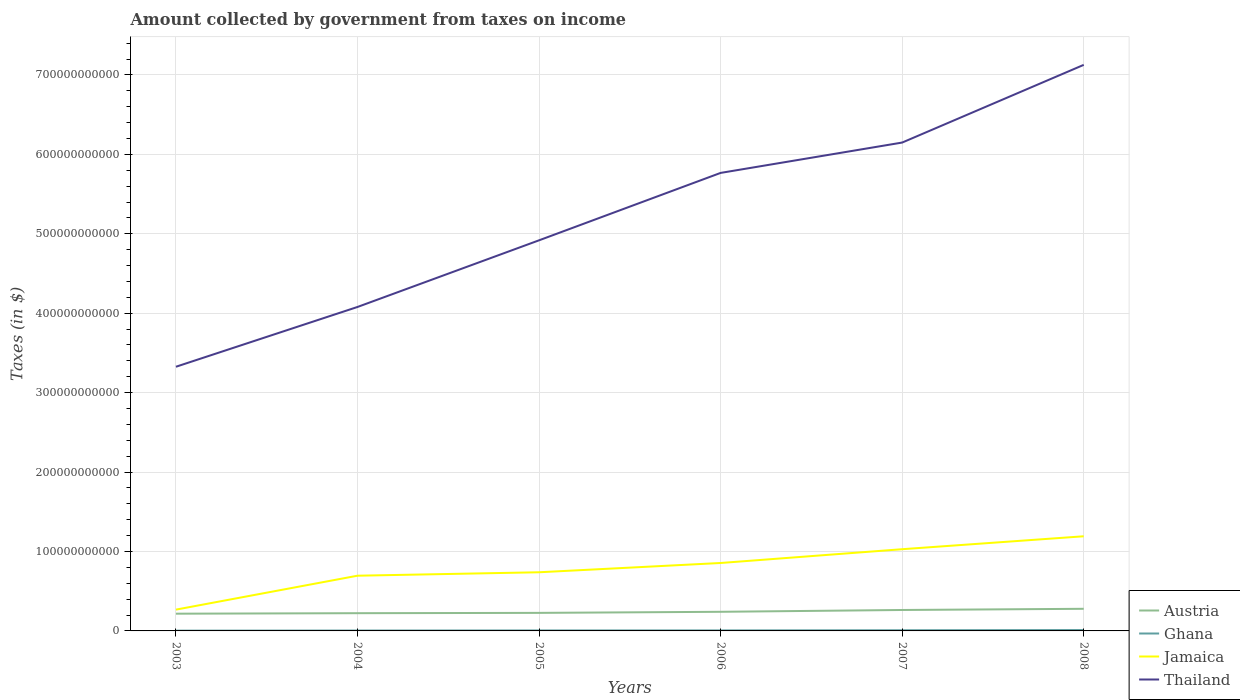How many different coloured lines are there?
Your answer should be compact. 4. Does the line corresponding to Ghana intersect with the line corresponding to Austria?
Make the answer very short. No. Is the number of lines equal to the number of legend labels?
Offer a very short reply. Yes. Across all years, what is the maximum amount collected by government from taxes on income in Thailand?
Your response must be concise. 3.33e+11. What is the total amount collected by government from taxes on income in Jamaica in the graph?
Offer a very short reply. -7.61e+1. What is the difference between the highest and the second highest amount collected by government from taxes on income in Jamaica?
Your answer should be very brief. 9.24e+1. How many lines are there?
Offer a terse response. 4. How many years are there in the graph?
Make the answer very short. 6. What is the difference between two consecutive major ticks on the Y-axis?
Your answer should be compact. 1.00e+11. What is the title of the graph?
Your answer should be compact. Amount collected by government from taxes on income. Does "China" appear as one of the legend labels in the graph?
Give a very brief answer. No. What is the label or title of the X-axis?
Provide a short and direct response. Years. What is the label or title of the Y-axis?
Keep it short and to the point. Taxes (in $). What is the Taxes (in $) of Austria in 2003?
Offer a very short reply. 2.17e+1. What is the Taxes (in $) of Ghana in 2003?
Offer a terse response. 3.57e+08. What is the Taxes (in $) in Jamaica in 2003?
Your answer should be compact. 2.68e+1. What is the Taxes (in $) of Thailand in 2003?
Give a very brief answer. 3.33e+11. What is the Taxes (in $) in Austria in 2004?
Ensure brevity in your answer.  2.23e+1. What is the Taxes (in $) of Ghana in 2004?
Provide a succinct answer. 4.86e+08. What is the Taxes (in $) of Jamaica in 2004?
Your answer should be very brief. 6.95e+1. What is the Taxes (in $) of Thailand in 2004?
Ensure brevity in your answer.  4.08e+11. What is the Taxes (in $) of Austria in 2005?
Give a very brief answer. 2.27e+1. What is the Taxes (in $) of Ghana in 2005?
Keep it short and to the point. 6.09e+08. What is the Taxes (in $) in Jamaica in 2005?
Your answer should be compact. 7.38e+1. What is the Taxes (in $) in Thailand in 2005?
Provide a succinct answer. 4.92e+11. What is the Taxes (in $) in Austria in 2006?
Ensure brevity in your answer.  2.41e+1. What is the Taxes (in $) in Ghana in 2006?
Your answer should be very brief. 6.58e+08. What is the Taxes (in $) of Jamaica in 2006?
Offer a terse response. 8.55e+1. What is the Taxes (in $) in Thailand in 2006?
Make the answer very short. 5.77e+11. What is the Taxes (in $) of Austria in 2007?
Your answer should be compact. 2.64e+1. What is the Taxes (in $) of Ghana in 2007?
Make the answer very short. 8.57e+08. What is the Taxes (in $) in Jamaica in 2007?
Keep it short and to the point. 1.03e+11. What is the Taxes (in $) of Thailand in 2007?
Your answer should be compact. 6.15e+11. What is the Taxes (in $) in Austria in 2008?
Offer a very short reply. 2.79e+1. What is the Taxes (in $) in Ghana in 2008?
Offer a very short reply. 1.13e+09. What is the Taxes (in $) in Jamaica in 2008?
Keep it short and to the point. 1.19e+11. What is the Taxes (in $) in Thailand in 2008?
Offer a terse response. 7.13e+11. Across all years, what is the maximum Taxes (in $) of Austria?
Provide a succinct answer. 2.79e+1. Across all years, what is the maximum Taxes (in $) of Ghana?
Provide a short and direct response. 1.13e+09. Across all years, what is the maximum Taxes (in $) of Jamaica?
Offer a very short reply. 1.19e+11. Across all years, what is the maximum Taxes (in $) of Thailand?
Provide a short and direct response. 7.13e+11. Across all years, what is the minimum Taxes (in $) in Austria?
Provide a short and direct response. 2.17e+1. Across all years, what is the minimum Taxes (in $) of Ghana?
Keep it short and to the point. 3.57e+08. Across all years, what is the minimum Taxes (in $) in Jamaica?
Keep it short and to the point. 2.68e+1. Across all years, what is the minimum Taxes (in $) of Thailand?
Provide a short and direct response. 3.33e+11. What is the total Taxes (in $) in Austria in the graph?
Your answer should be compact. 1.45e+11. What is the total Taxes (in $) in Ghana in the graph?
Offer a terse response. 4.10e+09. What is the total Taxes (in $) of Jamaica in the graph?
Ensure brevity in your answer.  4.78e+11. What is the total Taxes (in $) in Thailand in the graph?
Give a very brief answer. 3.14e+12. What is the difference between the Taxes (in $) of Austria in 2003 and that in 2004?
Provide a succinct answer. -6.12e+08. What is the difference between the Taxes (in $) of Ghana in 2003 and that in 2004?
Give a very brief answer. -1.29e+08. What is the difference between the Taxes (in $) of Jamaica in 2003 and that in 2004?
Your response must be concise. -4.27e+1. What is the difference between the Taxes (in $) of Thailand in 2003 and that in 2004?
Your answer should be very brief. -7.53e+1. What is the difference between the Taxes (in $) in Austria in 2003 and that in 2005?
Offer a terse response. -1.02e+09. What is the difference between the Taxes (in $) in Ghana in 2003 and that in 2005?
Provide a succinct answer. -2.52e+08. What is the difference between the Taxes (in $) of Jamaica in 2003 and that in 2005?
Keep it short and to the point. -4.70e+1. What is the difference between the Taxes (in $) in Thailand in 2003 and that in 2005?
Your answer should be very brief. -1.59e+11. What is the difference between the Taxes (in $) of Austria in 2003 and that in 2006?
Offer a terse response. -2.36e+09. What is the difference between the Taxes (in $) in Ghana in 2003 and that in 2006?
Your answer should be compact. -3.01e+08. What is the difference between the Taxes (in $) of Jamaica in 2003 and that in 2006?
Keep it short and to the point. -5.87e+1. What is the difference between the Taxes (in $) in Thailand in 2003 and that in 2006?
Offer a terse response. -2.44e+11. What is the difference between the Taxes (in $) in Austria in 2003 and that in 2007?
Your answer should be very brief. -4.66e+09. What is the difference between the Taxes (in $) in Ghana in 2003 and that in 2007?
Ensure brevity in your answer.  -5.01e+08. What is the difference between the Taxes (in $) of Jamaica in 2003 and that in 2007?
Provide a succinct answer. -7.61e+1. What is the difference between the Taxes (in $) of Thailand in 2003 and that in 2007?
Provide a succinct answer. -2.82e+11. What is the difference between the Taxes (in $) of Austria in 2003 and that in 2008?
Provide a short and direct response. -6.15e+09. What is the difference between the Taxes (in $) in Ghana in 2003 and that in 2008?
Your answer should be very brief. -7.78e+08. What is the difference between the Taxes (in $) of Jamaica in 2003 and that in 2008?
Your response must be concise. -9.24e+1. What is the difference between the Taxes (in $) in Thailand in 2003 and that in 2008?
Ensure brevity in your answer.  -3.80e+11. What is the difference between the Taxes (in $) of Austria in 2004 and that in 2005?
Your response must be concise. -4.04e+08. What is the difference between the Taxes (in $) of Ghana in 2004 and that in 2005?
Provide a succinct answer. -1.23e+08. What is the difference between the Taxes (in $) in Jamaica in 2004 and that in 2005?
Make the answer very short. -4.33e+09. What is the difference between the Taxes (in $) of Thailand in 2004 and that in 2005?
Offer a very short reply. -8.39e+1. What is the difference between the Taxes (in $) of Austria in 2004 and that in 2006?
Make the answer very short. -1.75e+09. What is the difference between the Taxes (in $) in Ghana in 2004 and that in 2006?
Provide a succinct answer. -1.72e+08. What is the difference between the Taxes (in $) of Jamaica in 2004 and that in 2006?
Your answer should be compact. -1.60e+1. What is the difference between the Taxes (in $) of Thailand in 2004 and that in 2006?
Your answer should be very brief. -1.69e+11. What is the difference between the Taxes (in $) of Austria in 2004 and that in 2007?
Provide a short and direct response. -4.04e+09. What is the difference between the Taxes (in $) of Ghana in 2004 and that in 2007?
Offer a terse response. -3.72e+08. What is the difference between the Taxes (in $) in Jamaica in 2004 and that in 2007?
Offer a terse response. -3.34e+1. What is the difference between the Taxes (in $) in Thailand in 2004 and that in 2007?
Provide a succinct answer. -2.07e+11. What is the difference between the Taxes (in $) of Austria in 2004 and that in 2008?
Your response must be concise. -5.54e+09. What is the difference between the Taxes (in $) of Ghana in 2004 and that in 2008?
Give a very brief answer. -6.49e+08. What is the difference between the Taxes (in $) of Jamaica in 2004 and that in 2008?
Make the answer very short. -4.97e+1. What is the difference between the Taxes (in $) in Thailand in 2004 and that in 2008?
Your response must be concise. -3.05e+11. What is the difference between the Taxes (in $) in Austria in 2005 and that in 2006?
Ensure brevity in your answer.  -1.35e+09. What is the difference between the Taxes (in $) in Ghana in 2005 and that in 2006?
Your response must be concise. -4.90e+07. What is the difference between the Taxes (in $) in Jamaica in 2005 and that in 2006?
Give a very brief answer. -1.17e+1. What is the difference between the Taxes (in $) in Thailand in 2005 and that in 2006?
Provide a short and direct response. -8.49e+1. What is the difference between the Taxes (in $) of Austria in 2005 and that in 2007?
Your answer should be compact. -3.64e+09. What is the difference between the Taxes (in $) of Ghana in 2005 and that in 2007?
Offer a terse response. -2.48e+08. What is the difference between the Taxes (in $) in Jamaica in 2005 and that in 2007?
Provide a short and direct response. -2.90e+1. What is the difference between the Taxes (in $) of Thailand in 2005 and that in 2007?
Your answer should be very brief. -1.23e+11. What is the difference between the Taxes (in $) in Austria in 2005 and that in 2008?
Your answer should be compact. -5.14e+09. What is the difference between the Taxes (in $) of Ghana in 2005 and that in 2008?
Your answer should be compact. -5.26e+08. What is the difference between the Taxes (in $) of Jamaica in 2005 and that in 2008?
Make the answer very short. -4.53e+1. What is the difference between the Taxes (in $) in Thailand in 2005 and that in 2008?
Provide a short and direct response. -2.21e+11. What is the difference between the Taxes (in $) of Austria in 2006 and that in 2007?
Your answer should be compact. -2.29e+09. What is the difference between the Taxes (in $) in Ghana in 2006 and that in 2007?
Your answer should be very brief. -1.99e+08. What is the difference between the Taxes (in $) in Jamaica in 2006 and that in 2007?
Ensure brevity in your answer.  -1.74e+1. What is the difference between the Taxes (in $) in Thailand in 2006 and that in 2007?
Your response must be concise. -3.82e+1. What is the difference between the Taxes (in $) of Austria in 2006 and that in 2008?
Provide a short and direct response. -3.79e+09. What is the difference between the Taxes (in $) in Ghana in 2006 and that in 2008?
Keep it short and to the point. -4.77e+08. What is the difference between the Taxes (in $) in Jamaica in 2006 and that in 2008?
Give a very brief answer. -3.36e+1. What is the difference between the Taxes (in $) of Thailand in 2006 and that in 2008?
Your response must be concise. -1.36e+11. What is the difference between the Taxes (in $) in Austria in 2007 and that in 2008?
Provide a succinct answer. -1.50e+09. What is the difference between the Taxes (in $) of Ghana in 2007 and that in 2008?
Provide a succinct answer. -2.77e+08. What is the difference between the Taxes (in $) in Jamaica in 2007 and that in 2008?
Make the answer very short. -1.63e+1. What is the difference between the Taxes (in $) of Thailand in 2007 and that in 2008?
Offer a terse response. -9.78e+1. What is the difference between the Taxes (in $) in Austria in 2003 and the Taxes (in $) in Ghana in 2004?
Offer a terse response. 2.12e+1. What is the difference between the Taxes (in $) of Austria in 2003 and the Taxes (in $) of Jamaica in 2004?
Offer a terse response. -4.78e+1. What is the difference between the Taxes (in $) of Austria in 2003 and the Taxes (in $) of Thailand in 2004?
Keep it short and to the point. -3.86e+11. What is the difference between the Taxes (in $) of Ghana in 2003 and the Taxes (in $) of Jamaica in 2004?
Offer a very short reply. -6.92e+1. What is the difference between the Taxes (in $) of Ghana in 2003 and the Taxes (in $) of Thailand in 2004?
Offer a terse response. -4.08e+11. What is the difference between the Taxes (in $) in Jamaica in 2003 and the Taxes (in $) in Thailand in 2004?
Provide a short and direct response. -3.81e+11. What is the difference between the Taxes (in $) in Austria in 2003 and the Taxes (in $) in Ghana in 2005?
Your answer should be compact. 2.11e+1. What is the difference between the Taxes (in $) in Austria in 2003 and the Taxes (in $) in Jamaica in 2005?
Give a very brief answer. -5.21e+1. What is the difference between the Taxes (in $) in Austria in 2003 and the Taxes (in $) in Thailand in 2005?
Make the answer very short. -4.70e+11. What is the difference between the Taxes (in $) of Ghana in 2003 and the Taxes (in $) of Jamaica in 2005?
Provide a short and direct response. -7.35e+1. What is the difference between the Taxes (in $) of Ghana in 2003 and the Taxes (in $) of Thailand in 2005?
Your answer should be very brief. -4.91e+11. What is the difference between the Taxes (in $) of Jamaica in 2003 and the Taxes (in $) of Thailand in 2005?
Keep it short and to the point. -4.65e+11. What is the difference between the Taxes (in $) in Austria in 2003 and the Taxes (in $) in Ghana in 2006?
Keep it short and to the point. 2.10e+1. What is the difference between the Taxes (in $) of Austria in 2003 and the Taxes (in $) of Jamaica in 2006?
Keep it short and to the point. -6.38e+1. What is the difference between the Taxes (in $) of Austria in 2003 and the Taxes (in $) of Thailand in 2006?
Offer a terse response. -5.55e+11. What is the difference between the Taxes (in $) of Ghana in 2003 and the Taxes (in $) of Jamaica in 2006?
Your answer should be very brief. -8.52e+1. What is the difference between the Taxes (in $) of Ghana in 2003 and the Taxes (in $) of Thailand in 2006?
Ensure brevity in your answer.  -5.76e+11. What is the difference between the Taxes (in $) in Jamaica in 2003 and the Taxes (in $) in Thailand in 2006?
Offer a very short reply. -5.50e+11. What is the difference between the Taxes (in $) of Austria in 2003 and the Taxes (in $) of Ghana in 2007?
Your answer should be very brief. 2.08e+1. What is the difference between the Taxes (in $) in Austria in 2003 and the Taxes (in $) in Jamaica in 2007?
Provide a succinct answer. -8.12e+1. What is the difference between the Taxes (in $) of Austria in 2003 and the Taxes (in $) of Thailand in 2007?
Give a very brief answer. -5.93e+11. What is the difference between the Taxes (in $) in Ghana in 2003 and the Taxes (in $) in Jamaica in 2007?
Ensure brevity in your answer.  -1.03e+11. What is the difference between the Taxes (in $) in Ghana in 2003 and the Taxes (in $) in Thailand in 2007?
Provide a short and direct response. -6.15e+11. What is the difference between the Taxes (in $) in Jamaica in 2003 and the Taxes (in $) in Thailand in 2007?
Offer a very short reply. -5.88e+11. What is the difference between the Taxes (in $) in Austria in 2003 and the Taxes (in $) in Ghana in 2008?
Keep it short and to the point. 2.06e+1. What is the difference between the Taxes (in $) of Austria in 2003 and the Taxes (in $) of Jamaica in 2008?
Offer a very short reply. -9.75e+1. What is the difference between the Taxes (in $) in Austria in 2003 and the Taxes (in $) in Thailand in 2008?
Ensure brevity in your answer.  -6.91e+11. What is the difference between the Taxes (in $) in Ghana in 2003 and the Taxes (in $) in Jamaica in 2008?
Your answer should be very brief. -1.19e+11. What is the difference between the Taxes (in $) of Ghana in 2003 and the Taxes (in $) of Thailand in 2008?
Your answer should be compact. -7.12e+11. What is the difference between the Taxes (in $) of Jamaica in 2003 and the Taxes (in $) of Thailand in 2008?
Make the answer very short. -6.86e+11. What is the difference between the Taxes (in $) in Austria in 2004 and the Taxes (in $) in Ghana in 2005?
Your answer should be very brief. 2.17e+1. What is the difference between the Taxes (in $) of Austria in 2004 and the Taxes (in $) of Jamaica in 2005?
Make the answer very short. -5.15e+1. What is the difference between the Taxes (in $) in Austria in 2004 and the Taxes (in $) in Thailand in 2005?
Your answer should be very brief. -4.69e+11. What is the difference between the Taxes (in $) in Ghana in 2004 and the Taxes (in $) in Jamaica in 2005?
Your answer should be very brief. -7.34e+1. What is the difference between the Taxes (in $) in Ghana in 2004 and the Taxes (in $) in Thailand in 2005?
Offer a terse response. -4.91e+11. What is the difference between the Taxes (in $) of Jamaica in 2004 and the Taxes (in $) of Thailand in 2005?
Provide a short and direct response. -4.22e+11. What is the difference between the Taxes (in $) in Austria in 2004 and the Taxes (in $) in Ghana in 2006?
Keep it short and to the point. 2.17e+1. What is the difference between the Taxes (in $) of Austria in 2004 and the Taxes (in $) of Jamaica in 2006?
Offer a terse response. -6.32e+1. What is the difference between the Taxes (in $) of Austria in 2004 and the Taxes (in $) of Thailand in 2006?
Your answer should be compact. -5.54e+11. What is the difference between the Taxes (in $) in Ghana in 2004 and the Taxes (in $) in Jamaica in 2006?
Keep it short and to the point. -8.50e+1. What is the difference between the Taxes (in $) in Ghana in 2004 and the Taxes (in $) in Thailand in 2006?
Offer a very short reply. -5.76e+11. What is the difference between the Taxes (in $) in Jamaica in 2004 and the Taxes (in $) in Thailand in 2006?
Offer a very short reply. -5.07e+11. What is the difference between the Taxes (in $) of Austria in 2004 and the Taxes (in $) of Ghana in 2007?
Ensure brevity in your answer.  2.15e+1. What is the difference between the Taxes (in $) in Austria in 2004 and the Taxes (in $) in Jamaica in 2007?
Provide a succinct answer. -8.06e+1. What is the difference between the Taxes (in $) in Austria in 2004 and the Taxes (in $) in Thailand in 2007?
Offer a terse response. -5.93e+11. What is the difference between the Taxes (in $) in Ghana in 2004 and the Taxes (in $) in Jamaica in 2007?
Offer a very short reply. -1.02e+11. What is the difference between the Taxes (in $) of Ghana in 2004 and the Taxes (in $) of Thailand in 2007?
Provide a short and direct response. -6.14e+11. What is the difference between the Taxes (in $) of Jamaica in 2004 and the Taxes (in $) of Thailand in 2007?
Offer a terse response. -5.45e+11. What is the difference between the Taxes (in $) in Austria in 2004 and the Taxes (in $) in Ghana in 2008?
Provide a short and direct response. 2.12e+1. What is the difference between the Taxes (in $) in Austria in 2004 and the Taxes (in $) in Jamaica in 2008?
Your answer should be very brief. -9.68e+1. What is the difference between the Taxes (in $) of Austria in 2004 and the Taxes (in $) of Thailand in 2008?
Provide a short and direct response. -6.90e+11. What is the difference between the Taxes (in $) of Ghana in 2004 and the Taxes (in $) of Jamaica in 2008?
Your answer should be compact. -1.19e+11. What is the difference between the Taxes (in $) of Ghana in 2004 and the Taxes (in $) of Thailand in 2008?
Your response must be concise. -7.12e+11. What is the difference between the Taxes (in $) of Jamaica in 2004 and the Taxes (in $) of Thailand in 2008?
Provide a short and direct response. -6.43e+11. What is the difference between the Taxes (in $) in Austria in 2005 and the Taxes (in $) in Ghana in 2006?
Your answer should be compact. 2.21e+1. What is the difference between the Taxes (in $) of Austria in 2005 and the Taxes (in $) of Jamaica in 2006?
Your answer should be compact. -6.28e+1. What is the difference between the Taxes (in $) in Austria in 2005 and the Taxes (in $) in Thailand in 2006?
Provide a short and direct response. -5.54e+11. What is the difference between the Taxes (in $) in Ghana in 2005 and the Taxes (in $) in Jamaica in 2006?
Ensure brevity in your answer.  -8.49e+1. What is the difference between the Taxes (in $) in Ghana in 2005 and the Taxes (in $) in Thailand in 2006?
Your answer should be very brief. -5.76e+11. What is the difference between the Taxes (in $) in Jamaica in 2005 and the Taxes (in $) in Thailand in 2006?
Your answer should be very brief. -5.03e+11. What is the difference between the Taxes (in $) of Austria in 2005 and the Taxes (in $) of Ghana in 2007?
Offer a very short reply. 2.19e+1. What is the difference between the Taxes (in $) of Austria in 2005 and the Taxes (in $) of Jamaica in 2007?
Make the answer very short. -8.02e+1. What is the difference between the Taxes (in $) of Austria in 2005 and the Taxes (in $) of Thailand in 2007?
Ensure brevity in your answer.  -5.92e+11. What is the difference between the Taxes (in $) of Ghana in 2005 and the Taxes (in $) of Jamaica in 2007?
Your response must be concise. -1.02e+11. What is the difference between the Taxes (in $) in Ghana in 2005 and the Taxes (in $) in Thailand in 2007?
Provide a succinct answer. -6.14e+11. What is the difference between the Taxes (in $) in Jamaica in 2005 and the Taxes (in $) in Thailand in 2007?
Keep it short and to the point. -5.41e+11. What is the difference between the Taxes (in $) of Austria in 2005 and the Taxes (in $) of Ghana in 2008?
Keep it short and to the point. 2.16e+1. What is the difference between the Taxes (in $) in Austria in 2005 and the Taxes (in $) in Jamaica in 2008?
Keep it short and to the point. -9.64e+1. What is the difference between the Taxes (in $) in Austria in 2005 and the Taxes (in $) in Thailand in 2008?
Provide a short and direct response. -6.90e+11. What is the difference between the Taxes (in $) in Ghana in 2005 and the Taxes (in $) in Jamaica in 2008?
Ensure brevity in your answer.  -1.19e+11. What is the difference between the Taxes (in $) of Ghana in 2005 and the Taxes (in $) of Thailand in 2008?
Keep it short and to the point. -7.12e+11. What is the difference between the Taxes (in $) in Jamaica in 2005 and the Taxes (in $) in Thailand in 2008?
Offer a terse response. -6.39e+11. What is the difference between the Taxes (in $) in Austria in 2006 and the Taxes (in $) in Ghana in 2007?
Your answer should be compact. 2.32e+1. What is the difference between the Taxes (in $) of Austria in 2006 and the Taxes (in $) of Jamaica in 2007?
Offer a very short reply. -7.88e+1. What is the difference between the Taxes (in $) of Austria in 2006 and the Taxes (in $) of Thailand in 2007?
Your answer should be compact. -5.91e+11. What is the difference between the Taxes (in $) of Ghana in 2006 and the Taxes (in $) of Jamaica in 2007?
Ensure brevity in your answer.  -1.02e+11. What is the difference between the Taxes (in $) of Ghana in 2006 and the Taxes (in $) of Thailand in 2007?
Offer a very short reply. -6.14e+11. What is the difference between the Taxes (in $) of Jamaica in 2006 and the Taxes (in $) of Thailand in 2007?
Give a very brief answer. -5.29e+11. What is the difference between the Taxes (in $) of Austria in 2006 and the Taxes (in $) of Ghana in 2008?
Provide a short and direct response. 2.29e+1. What is the difference between the Taxes (in $) in Austria in 2006 and the Taxes (in $) in Jamaica in 2008?
Keep it short and to the point. -9.51e+1. What is the difference between the Taxes (in $) in Austria in 2006 and the Taxes (in $) in Thailand in 2008?
Offer a terse response. -6.89e+11. What is the difference between the Taxes (in $) of Ghana in 2006 and the Taxes (in $) of Jamaica in 2008?
Provide a succinct answer. -1.19e+11. What is the difference between the Taxes (in $) in Ghana in 2006 and the Taxes (in $) in Thailand in 2008?
Offer a very short reply. -7.12e+11. What is the difference between the Taxes (in $) in Jamaica in 2006 and the Taxes (in $) in Thailand in 2008?
Give a very brief answer. -6.27e+11. What is the difference between the Taxes (in $) in Austria in 2007 and the Taxes (in $) in Ghana in 2008?
Provide a succinct answer. 2.52e+1. What is the difference between the Taxes (in $) of Austria in 2007 and the Taxes (in $) of Jamaica in 2008?
Provide a short and direct response. -9.28e+1. What is the difference between the Taxes (in $) in Austria in 2007 and the Taxes (in $) in Thailand in 2008?
Provide a succinct answer. -6.86e+11. What is the difference between the Taxes (in $) of Ghana in 2007 and the Taxes (in $) of Jamaica in 2008?
Provide a short and direct response. -1.18e+11. What is the difference between the Taxes (in $) in Ghana in 2007 and the Taxes (in $) in Thailand in 2008?
Provide a succinct answer. -7.12e+11. What is the difference between the Taxes (in $) of Jamaica in 2007 and the Taxes (in $) of Thailand in 2008?
Provide a succinct answer. -6.10e+11. What is the average Taxes (in $) in Austria per year?
Provide a succinct answer. 2.42e+1. What is the average Taxes (in $) in Ghana per year?
Your response must be concise. 6.84e+08. What is the average Taxes (in $) in Jamaica per year?
Your answer should be compact. 7.96e+1. What is the average Taxes (in $) of Thailand per year?
Offer a very short reply. 5.23e+11. In the year 2003, what is the difference between the Taxes (in $) in Austria and Taxes (in $) in Ghana?
Keep it short and to the point. 2.13e+1. In the year 2003, what is the difference between the Taxes (in $) in Austria and Taxes (in $) in Jamaica?
Provide a short and direct response. -5.11e+09. In the year 2003, what is the difference between the Taxes (in $) in Austria and Taxes (in $) in Thailand?
Ensure brevity in your answer.  -3.11e+11. In the year 2003, what is the difference between the Taxes (in $) in Ghana and Taxes (in $) in Jamaica?
Ensure brevity in your answer.  -2.65e+1. In the year 2003, what is the difference between the Taxes (in $) of Ghana and Taxes (in $) of Thailand?
Your answer should be very brief. -3.32e+11. In the year 2003, what is the difference between the Taxes (in $) of Jamaica and Taxes (in $) of Thailand?
Your response must be concise. -3.06e+11. In the year 2004, what is the difference between the Taxes (in $) in Austria and Taxes (in $) in Ghana?
Offer a very short reply. 2.18e+1. In the year 2004, what is the difference between the Taxes (in $) of Austria and Taxes (in $) of Jamaica?
Your response must be concise. -4.72e+1. In the year 2004, what is the difference between the Taxes (in $) of Austria and Taxes (in $) of Thailand?
Keep it short and to the point. -3.86e+11. In the year 2004, what is the difference between the Taxes (in $) of Ghana and Taxes (in $) of Jamaica?
Provide a short and direct response. -6.90e+1. In the year 2004, what is the difference between the Taxes (in $) of Ghana and Taxes (in $) of Thailand?
Offer a terse response. -4.07e+11. In the year 2004, what is the difference between the Taxes (in $) of Jamaica and Taxes (in $) of Thailand?
Give a very brief answer. -3.38e+11. In the year 2005, what is the difference between the Taxes (in $) in Austria and Taxes (in $) in Ghana?
Provide a short and direct response. 2.21e+1. In the year 2005, what is the difference between the Taxes (in $) in Austria and Taxes (in $) in Jamaica?
Offer a terse response. -5.11e+1. In the year 2005, what is the difference between the Taxes (in $) of Austria and Taxes (in $) of Thailand?
Offer a very short reply. -4.69e+11. In the year 2005, what is the difference between the Taxes (in $) in Ghana and Taxes (in $) in Jamaica?
Your response must be concise. -7.32e+1. In the year 2005, what is the difference between the Taxes (in $) of Ghana and Taxes (in $) of Thailand?
Give a very brief answer. -4.91e+11. In the year 2005, what is the difference between the Taxes (in $) of Jamaica and Taxes (in $) of Thailand?
Give a very brief answer. -4.18e+11. In the year 2006, what is the difference between the Taxes (in $) in Austria and Taxes (in $) in Ghana?
Provide a succinct answer. 2.34e+1. In the year 2006, what is the difference between the Taxes (in $) in Austria and Taxes (in $) in Jamaica?
Your answer should be compact. -6.15e+1. In the year 2006, what is the difference between the Taxes (in $) in Austria and Taxes (in $) in Thailand?
Make the answer very short. -5.53e+11. In the year 2006, what is the difference between the Taxes (in $) in Ghana and Taxes (in $) in Jamaica?
Make the answer very short. -8.49e+1. In the year 2006, what is the difference between the Taxes (in $) of Ghana and Taxes (in $) of Thailand?
Your answer should be compact. -5.76e+11. In the year 2006, what is the difference between the Taxes (in $) of Jamaica and Taxes (in $) of Thailand?
Ensure brevity in your answer.  -4.91e+11. In the year 2007, what is the difference between the Taxes (in $) of Austria and Taxes (in $) of Ghana?
Make the answer very short. 2.55e+1. In the year 2007, what is the difference between the Taxes (in $) of Austria and Taxes (in $) of Jamaica?
Your answer should be compact. -7.65e+1. In the year 2007, what is the difference between the Taxes (in $) of Austria and Taxes (in $) of Thailand?
Your answer should be very brief. -5.89e+11. In the year 2007, what is the difference between the Taxes (in $) of Ghana and Taxes (in $) of Jamaica?
Give a very brief answer. -1.02e+11. In the year 2007, what is the difference between the Taxes (in $) in Ghana and Taxes (in $) in Thailand?
Your answer should be compact. -6.14e+11. In the year 2007, what is the difference between the Taxes (in $) of Jamaica and Taxes (in $) of Thailand?
Your answer should be very brief. -5.12e+11. In the year 2008, what is the difference between the Taxes (in $) in Austria and Taxes (in $) in Ghana?
Offer a very short reply. 2.67e+1. In the year 2008, what is the difference between the Taxes (in $) in Austria and Taxes (in $) in Jamaica?
Keep it short and to the point. -9.13e+1. In the year 2008, what is the difference between the Taxes (in $) in Austria and Taxes (in $) in Thailand?
Offer a terse response. -6.85e+11. In the year 2008, what is the difference between the Taxes (in $) in Ghana and Taxes (in $) in Jamaica?
Provide a short and direct response. -1.18e+11. In the year 2008, what is the difference between the Taxes (in $) in Ghana and Taxes (in $) in Thailand?
Your answer should be compact. -7.12e+11. In the year 2008, what is the difference between the Taxes (in $) in Jamaica and Taxes (in $) in Thailand?
Make the answer very short. -5.94e+11. What is the ratio of the Taxes (in $) of Austria in 2003 to that in 2004?
Keep it short and to the point. 0.97. What is the ratio of the Taxes (in $) of Ghana in 2003 to that in 2004?
Provide a short and direct response. 0.73. What is the ratio of the Taxes (in $) of Jamaica in 2003 to that in 2004?
Keep it short and to the point. 0.39. What is the ratio of the Taxes (in $) in Thailand in 2003 to that in 2004?
Give a very brief answer. 0.82. What is the ratio of the Taxes (in $) of Austria in 2003 to that in 2005?
Your response must be concise. 0.96. What is the ratio of the Taxes (in $) in Ghana in 2003 to that in 2005?
Provide a succinct answer. 0.59. What is the ratio of the Taxes (in $) of Jamaica in 2003 to that in 2005?
Your answer should be very brief. 0.36. What is the ratio of the Taxes (in $) of Thailand in 2003 to that in 2005?
Keep it short and to the point. 0.68. What is the ratio of the Taxes (in $) of Austria in 2003 to that in 2006?
Give a very brief answer. 0.9. What is the ratio of the Taxes (in $) in Ghana in 2003 to that in 2006?
Provide a succinct answer. 0.54. What is the ratio of the Taxes (in $) of Jamaica in 2003 to that in 2006?
Keep it short and to the point. 0.31. What is the ratio of the Taxes (in $) of Thailand in 2003 to that in 2006?
Your response must be concise. 0.58. What is the ratio of the Taxes (in $) in Austria in 2003 to that in 2007?
Offer a terse response. 0.82. What is the ratio of the Taxes (in $) of Ghana in 2003 to that in 2007?
Ensure brevity in your answer.  0.42. What is the ratio of the Taxes (in $) in Jamaica in 2003 to that in 2007?
Ensure brevity in your answer.  0.26. What is the ratio of the Taxes (in $) of Thailand in 2003 to that in 2007?
Ensure brevity in your answer.  0.54. What is the ratio of the Taxes (in $) in Austria in 2003 to that in 2008?
Provide a short and direct response. 0.78. What is the ratio of the Taxes (in $) in Ghana in 2003 to that in 2008?
Provide a succinct answer. 0.31. What is the ratio of the Taxes (in $) of Jamaica in 2003 to that in 2008?
Provide a succinct answer. 0.23. What is the ratio of the Taxes (in $) in Thailand in 2003 to that in 2008?
Your response must be concise. 0.47. What is the ratio of the Taxes (in $) of Austria in 2004 to that in 2005?
Your response must be concise. 0.98. What is the ratio of the Taxes (in $) in Ghana in 2004 to that in 2005?
Provide a succinct answer. 0.8. What is the ratio of the Taxes (in $) in Jamaica in 2004 to that in 2005?
Ensure brevity in your answer.  0.94. What is the ratio of the Taxes (in $) in Thailand in 2004 to that in 2005?
Your answer should be very brief. 0.83. What is the ratio of the Taxes (in $) in Austria in 2004 to that in 2006?
Offer a very short reply. 0.93. What is the ratio of the Taxes (in $) in Ghana in 2004 to that in 2006?
Your response must be concise. 0.74. What is the ratio of the Taxes (in $) in Jamaica in 2004 to that in 2006?
Your response must be concise. 0.81. What is the ratio of the Taxes (in $) of Thailand in 2004 to that in 2006?
Provide a succinct answer. 0.71. What is the ratio of the Taxes (in $) in Austria in 2004 to that in 2007?
Offer a terse response. 0.85. What is the ratio of the Taxes (in $) in Ghana in 2004 to that in 2007?
Provide a short and direct response. 0.57. What is the ratio of the Taxes (in $) of Jamaica in 2004 to that in 2007?
Your response must be concise. 0.68. What is the ratio of the Taxes (in $) in Thailand in 2004 to that in 2007?
Make the answer very short. 0.66. What is the ratio of the Taxes (in $) in Austria in 2004 to that in 2008?
Make the answer very short. 0.8. What is the ratio of the Taxes (in $) of Ghana in 2004 to that in 2008?
Your response must be concise. 0.43. What is the ratio of the Taxes (in $) of Jamaica in 2004 to that in 2008?
Give a very brief answer. 0.58. What is the ratio of the Taxes (in $) of Thailand in 2004 to that in 2008?
Your answer should be compact. 0.57. What is the ratio of the Taxes (in $) in Austria in 2005 to that in 2006?
Keep it short and to the point. 0.94. What is the ratio of the Taxes (in $) in Ghana in 2005 to that in 2006?
Provide a succinct answer. 0.93. What is the ratio of the Taxes (in $) of Jamaica in 2005 to that in 2006?
Ensure brevity in your answer.  0.86. What is the ratio of the Taxes (in $) of Thailand in 2005 to that in 2006?
Keep it short and to the point. 0.85. What is the ratio of the Taxes (in $) in Austria in 2005 to that in 2007?
Keep it short and to the point. 0.86. What is the ratio of the Taxes (in $) of Ghana in 2005 to that in 2007?
Your response must be concise. 0.71. What is the ratio of the Taxes (in $) of Jamaica in 2005 to that in 2007?
Your response must be concise. 0.72. What is the ratio of the Taxes (in $) of Thailand in 2005 to that in 2007?
Give a very brief answer. 0.8. What is the ratio of the Taxes (in $) of Austria in 2005 to that in 2008?
Your response must be concise. 0.82. What is the ratio of the Taxes (in $) in Ghana in 2005 to that in 2008?
Provide a short and direct response. 0.54. What is the ratio of the Taxes (in $) in Jamaica in 2005 to that in 2008?
Provide a succinct answer. 0.62. What is the ratio of the Taxes (in $) of Thailand in 2005 to that in 2008?
Make the answer very short. 0.69. What is the ratio of the Taxes (in $) in Austria in 2006 to that in 2007?
Your response must be concise. 0.91. What is the ratio of the Taxes (in $) of Ghana in 2006 to that in 2007?
Your answer should be very brief. 0.77. What is the ratio of the Taxes (in $) of Jamaica in 2006 to that in 2007?
Keep it short and to the point. 0.83. What is the ratio of the Taxes (in $) in Thailand in 2006 to that in 2007?
Your answer should be compact. 0.94. What is the ratio of the Taxes (in $) of Austria in 2006 to that in 2008?
Keep it short and to the point. 0.86. What is the ratio of the Taxes (in $) of Ghana in 2006 to that in 2008?
Your answer should be compact. 0.58. What is the ratio of the Taxes (in $) of Jamaica in 2006 to that in 2008?
Your answer should be very brief. 0.72. What is the ratio of the Taxes (in $) of Thailand in 2006 to that in 2008?
Your answer should be compact. 0.81. What is the ratio of the Taxes (in $) of Austria in 2007 to that in 2008?
Provide a succinct answer. 0.95. What is the ratio of the Taxes (in $) of Ghana in 2007 to that in 2008?
Provide a short and direct response. 0.76. What is the ratio of the Taxes (in $) in Jamaica in 2007 to that in 2008?
Ensure brevity in your answer.  0.86. What is the ratio of the Taxes (in $) in Thailand in 2007 to that in 2008?
Keep it short and to the point. 0.86. What is the difference between the highest and the second highest Taxes (in $) of Austria?
Make the answer very short. 1.50e+09. What is the difference between the highest and the second highest Taxes (in $) in Ghana?
Your response must be concise. 2.77e+08. What is the difference between the highest and the second highest Taxes (in $) in Jamaica?
Offer a terse response. 1.63e+1. What is the difference between the highest and the second highest Taxes (in $) of Thailand?
Ensure brevity in your answer.  9.78e+1. What is the difference between the highest and the lowest Taxes (in $) in Austria?
Your response must be concise. 6.15e+09. What is the difference between the highest and the lowest Taxes (in $) of Ghana?
Keep it short and to the point. 7.78e+08. What is the difference between the highest and the lowest Taxes (in $) of Jamaica?
Make the answer very short. 9.24e+1. What is the difference between the highest and the lowest Taxes (in $) in Thailand?
Offer a terse response. 3.80e+11. 